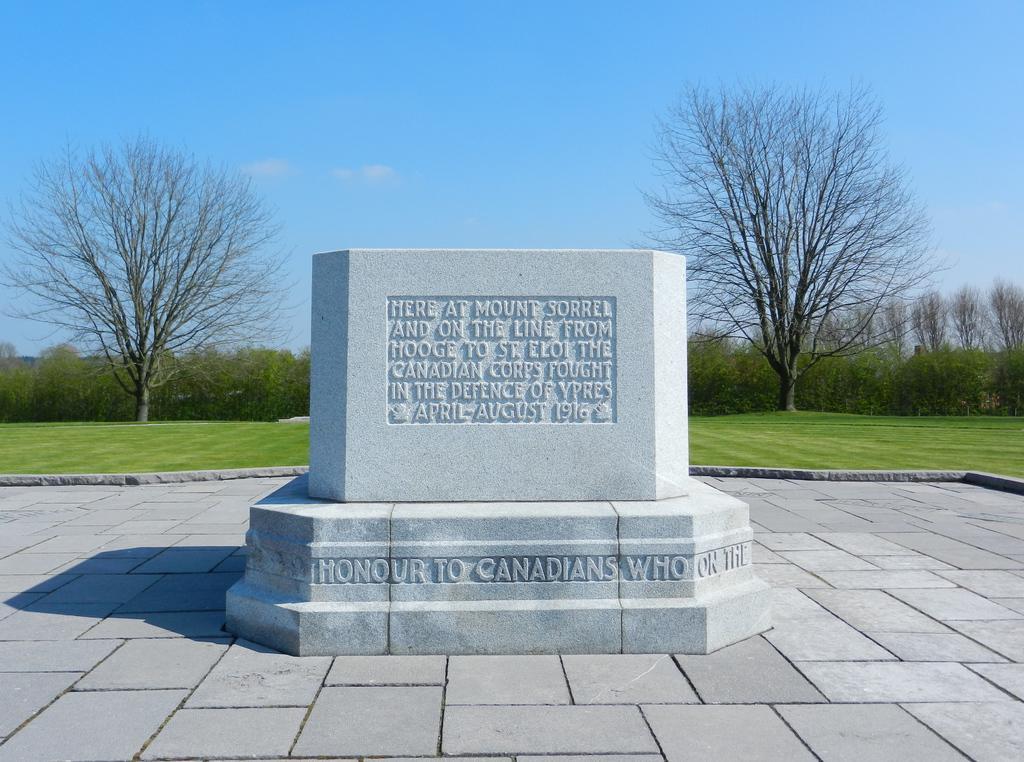Please provide a concise description of this image. In this image there is a floor, On the floor there is a stone with the text. And at the background there is a grass, Trees and a sky. 